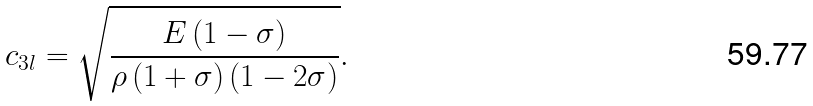Convert formula to latex. <formula><loc_0><loc_0><loc_500><loc_500>c _ { 3 l } = \sqrt { \frac { E \left ( 1 - \sigma \right ) } { \rho \left ( 1 + \sigma \right ) \left ( 1 - 2 \sigma \right ) } } .</formula> 